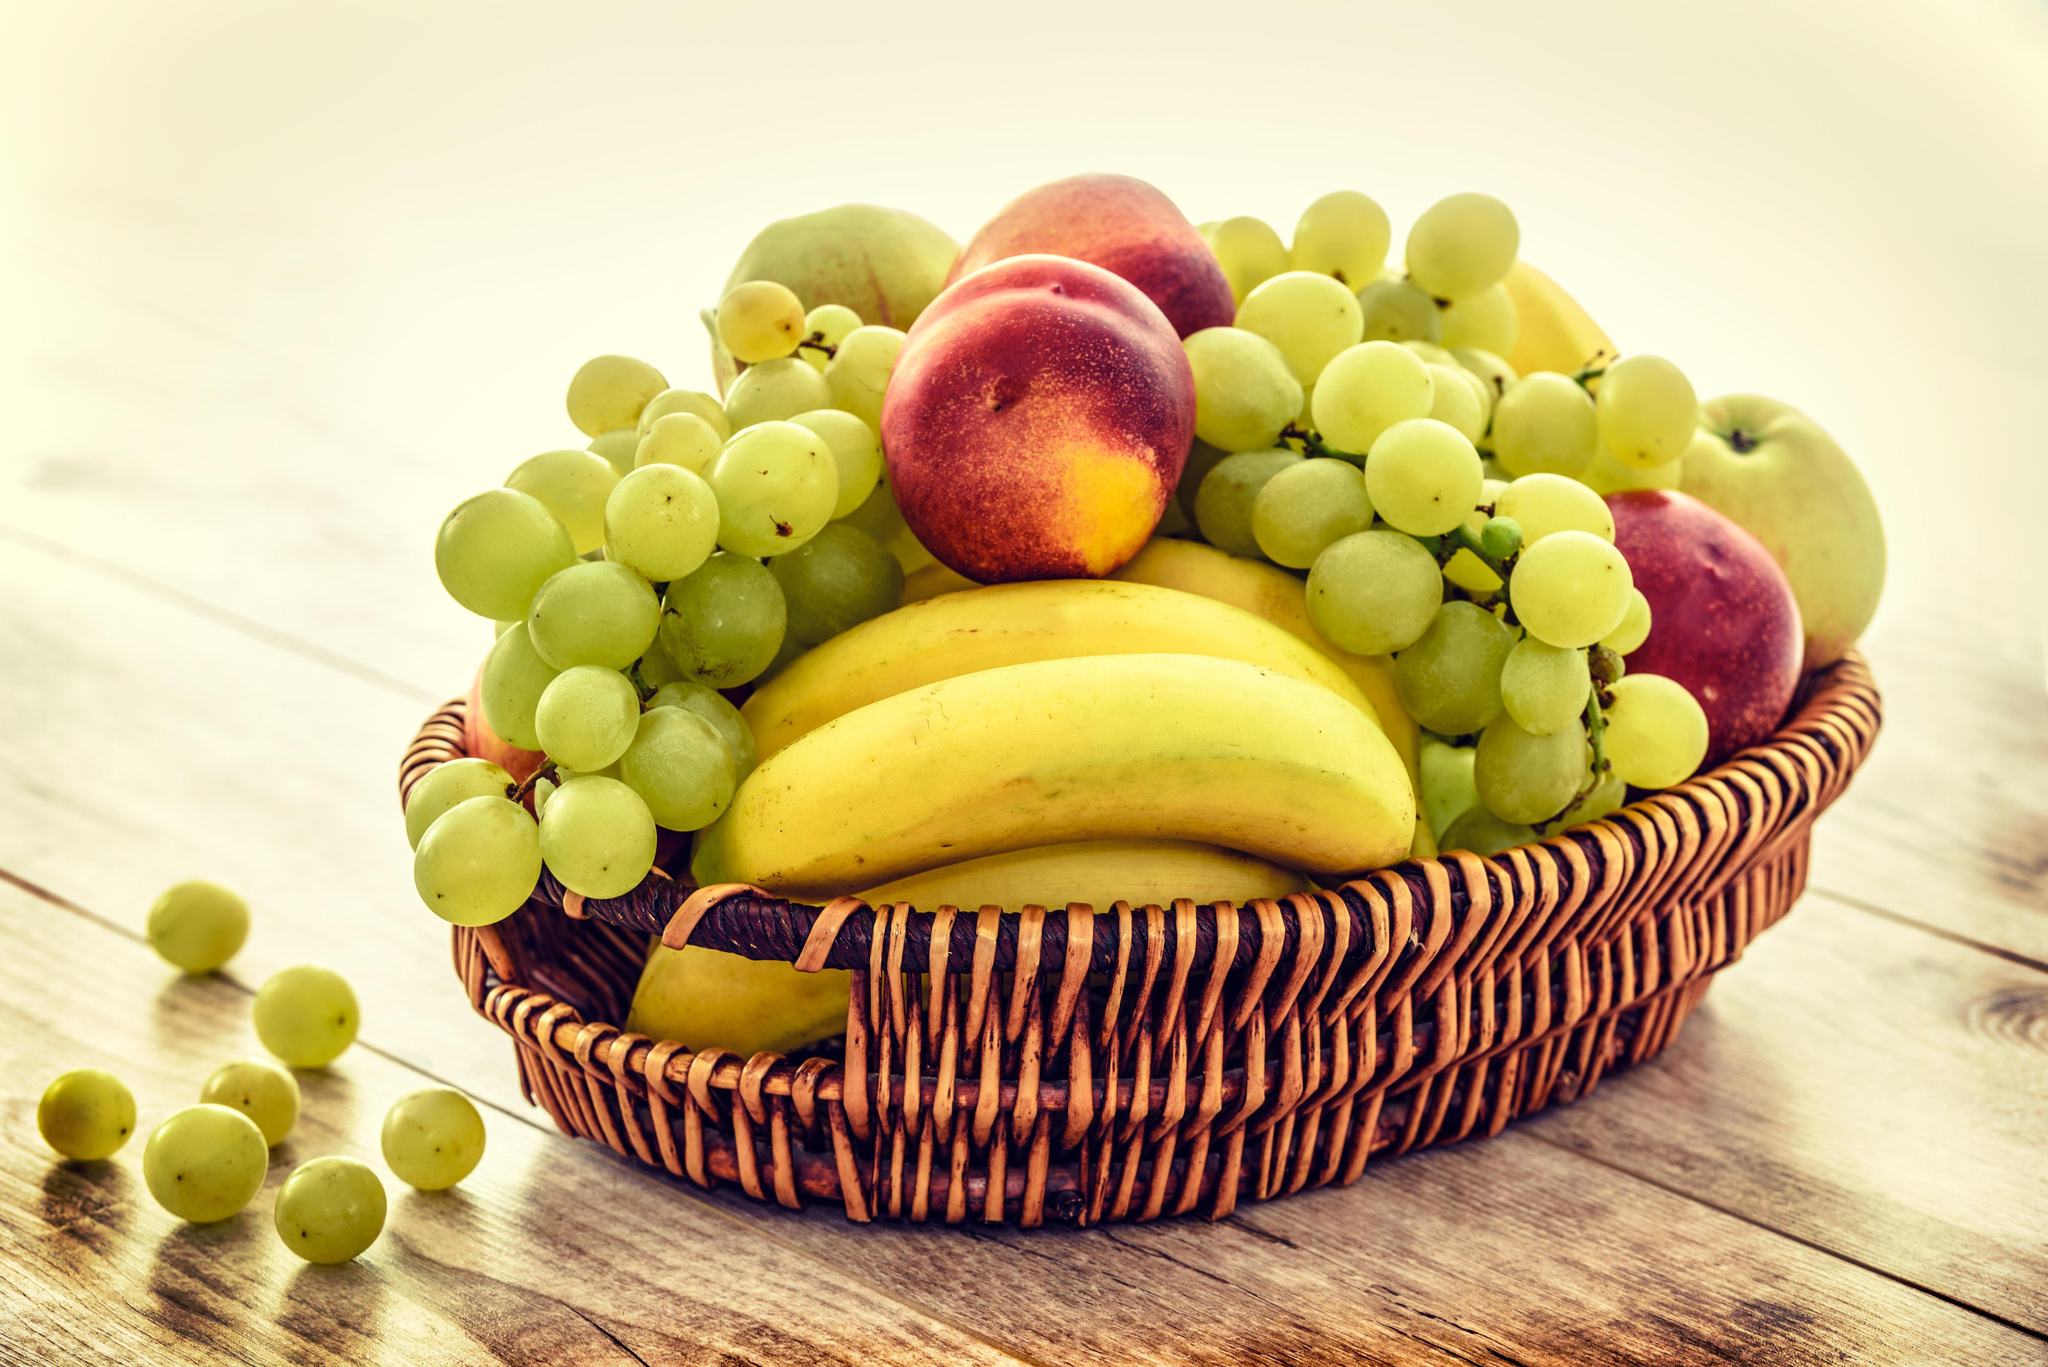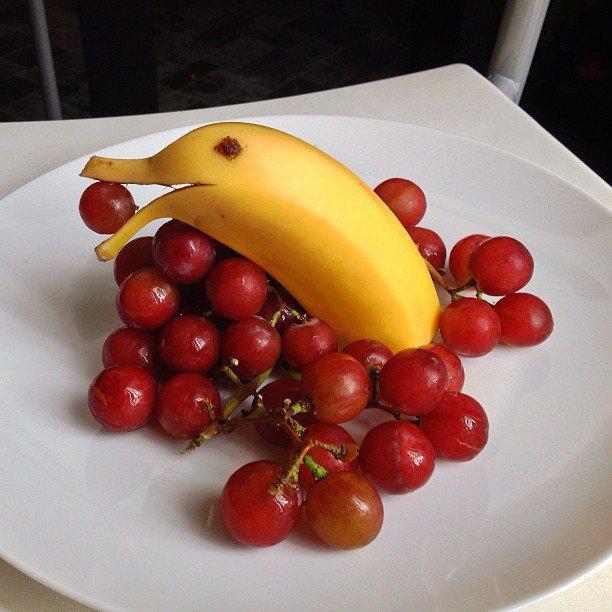The first image is the image on the left, the second image is the image on the right. Given the left and right images, does the statement "There are some sliced bananas." hold true? Answer yes or no. No. The first image is the image on the left, the second image is the image on the right. Analyze the images presented: Is the assertion "An image shows a basket filled with unpeeled bananas, green grapes, and reddish-purple plums." valid? Answer yes or no. Yes. 